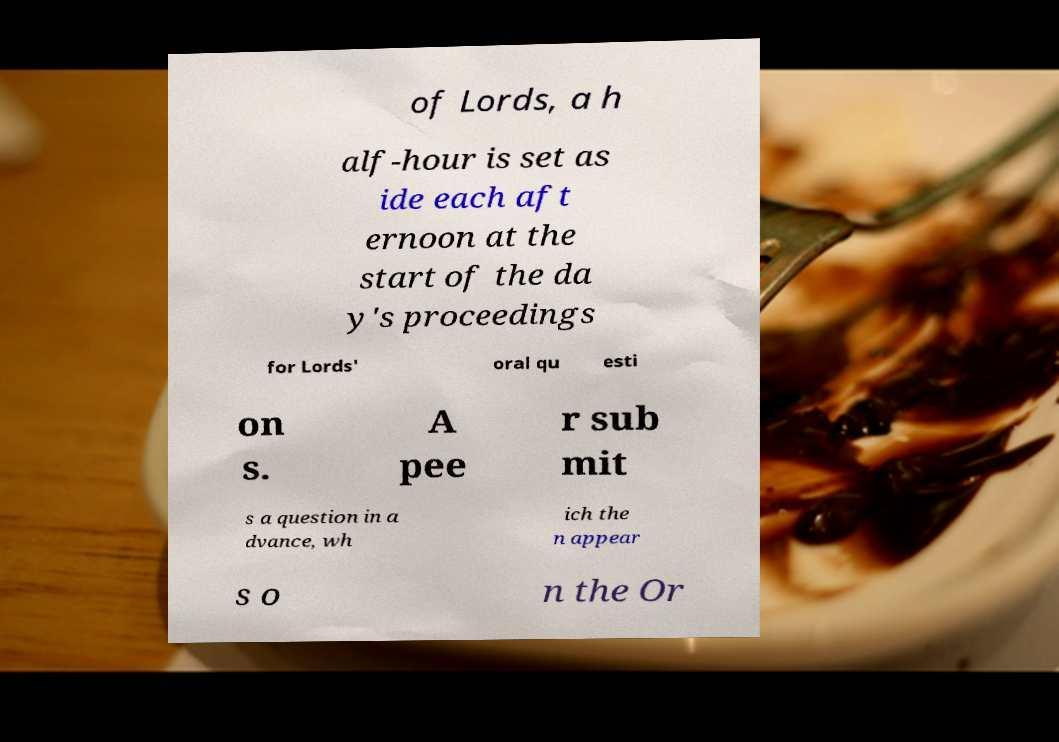What messages or text are displayed in this image? I need them in a readable, typed format. of Lords, a h alf-hour is set as ide each aft ernoon at the start of the da y's proceedings for Lords' oral qu esti on s. A pee r sub mit s a question in a dvance, wh ich the n appear s o n the Or 